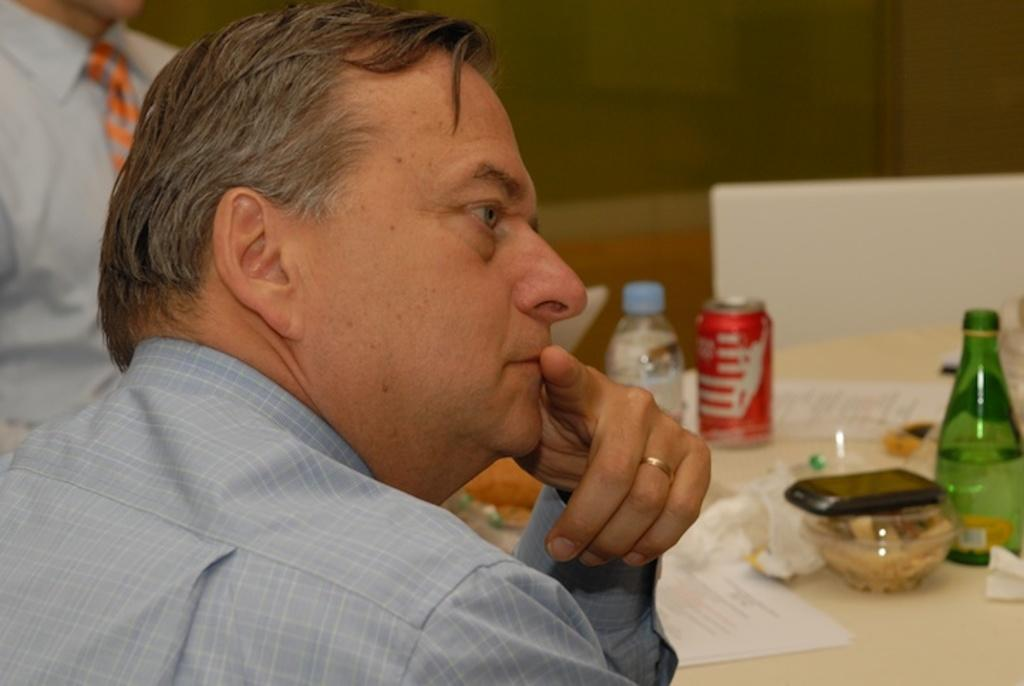What is the position of the person in relation to the table in the image? There is a person in front of the table. What object is on the table in the image? There is a mobile on the table. What other items can be seen on the table? There are bottles, a tin, and papers on the table. Is there anyone else visible in the image? Yes, there is another person standing to the left. What type of beast is present in the image? There is no beast present in the image. What color is the copper in the image? There is no copper present in the image. 